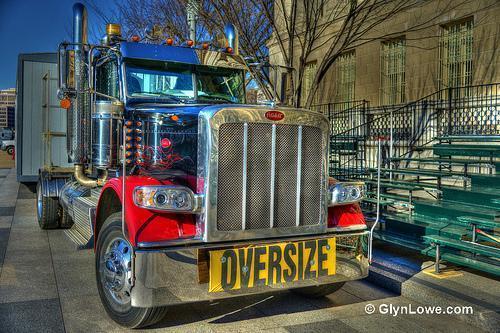How many trucks are there?
Give a very brief answer. 1. How many people are sitting on the top of the truck?
Give a very brief answer. 0. 